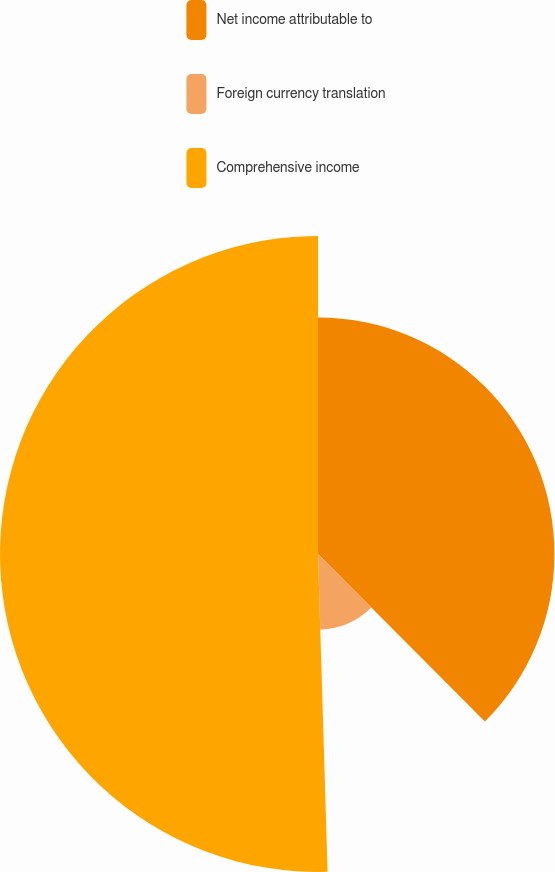<chart> <loc_0><loc_0><loc_500><loc_500><pie_chart><fcel>Net income attributable to<fcel>Foreign currency translation<fcel>Comprehensive income<nl><fcel>37.53%<fcel>11.99%<fcel>50.48%<nl></chart> 